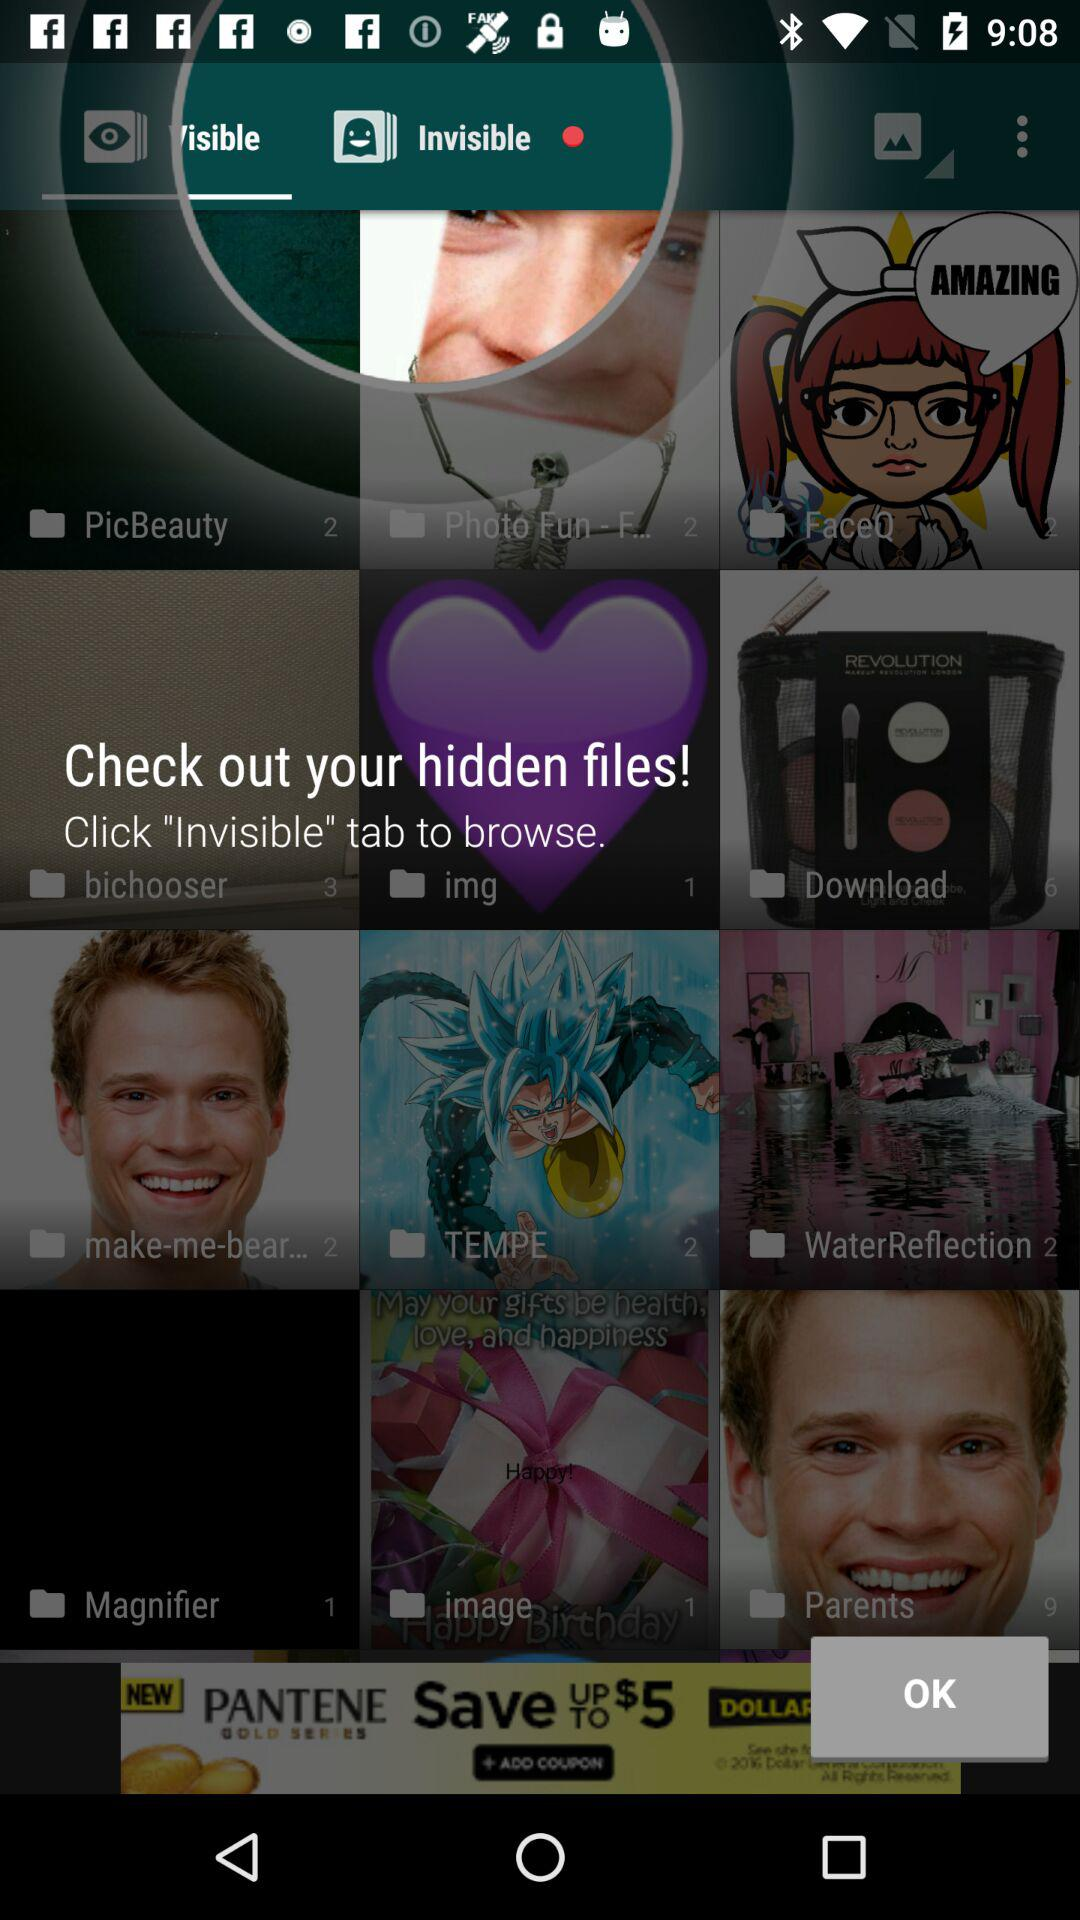How many files are there in "Download" folder? There are 6 files in "Download" folder. 